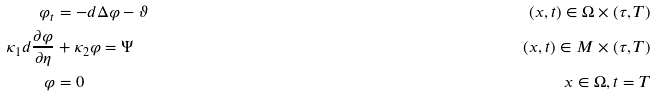<formula> <loc_0><loc_0><loc_500><loc_500>\varphi _ { t } & = - d \Delta \varphi - \vartheta & ( x , t ) \in \Omega \times ( \tau , T ) \\ \kappa _ { 1 } d \frac { \partial \varphi } { \partial \eta } & + \kappa _ { 2 } \varphi = \Psi & ( x , t ) \in M \times ( \tau , T ) \\ \varphi & = 0 & x \in \Omega , t = T</formula> 